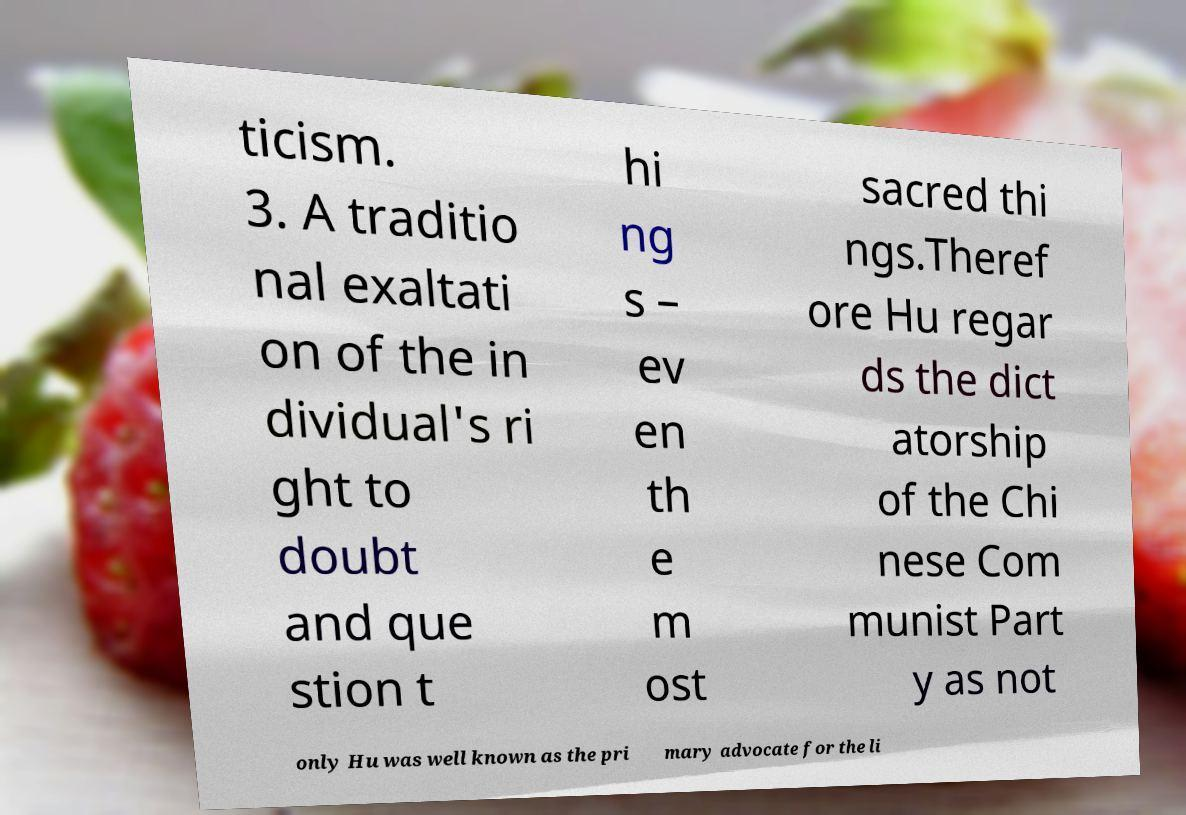Can you read and provide the text displayed in the image?This photo seems to have some interesting text. Can you extract and type it out for me? ticism. 3. A traditio nal exaltati on of the in dividual's ri ght to doubt and que stion t hi ng s – ev en th e m ost sacred thi ngs.Theref ore Hu regar ds the dict atorship of the Chi nese Com munist Part y as not only Hu was well known as the pri mary advocate for the li 